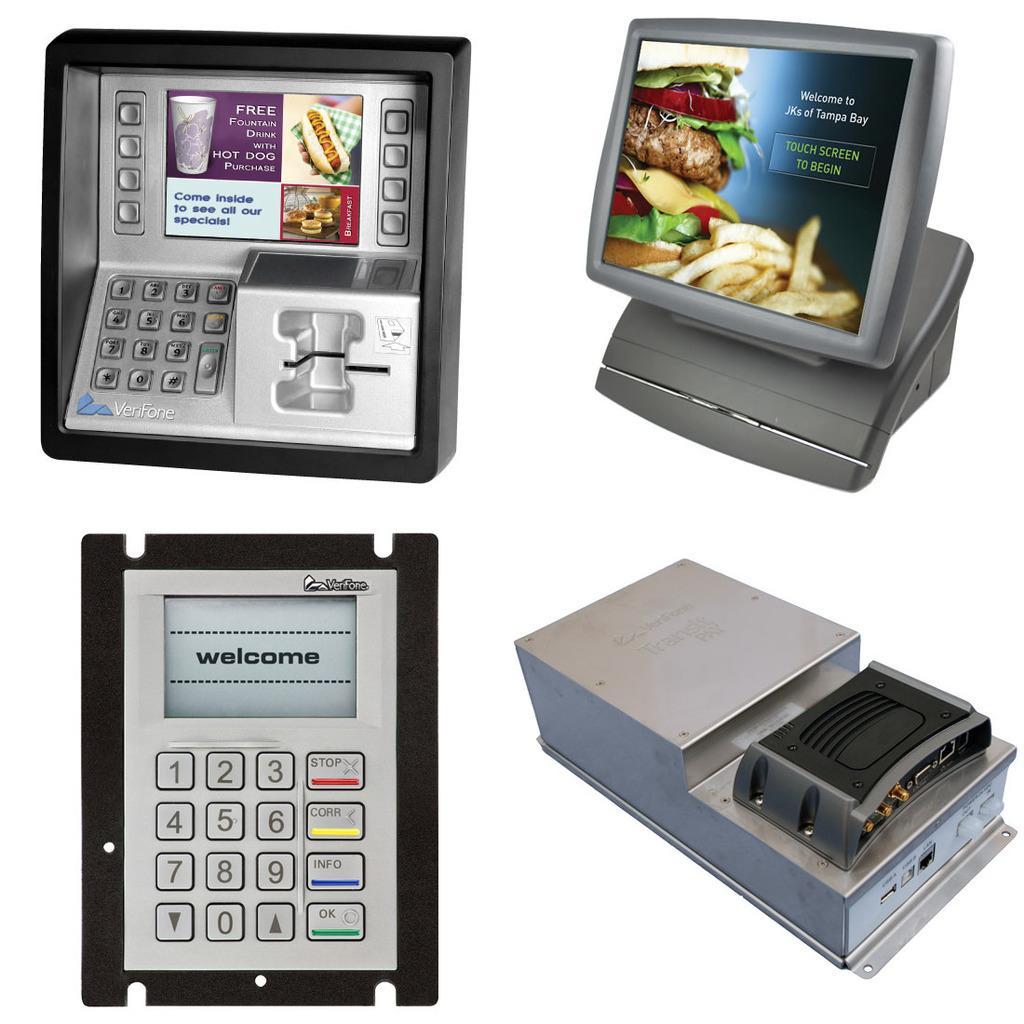Could you give a brief overview of what you see in this image? In this image there are electronic devices, there is an object that looks like a calculator, there is a screen, there is text on the screen, there is food, there is a glass, there is text on the device, the background of the image is white in color. 